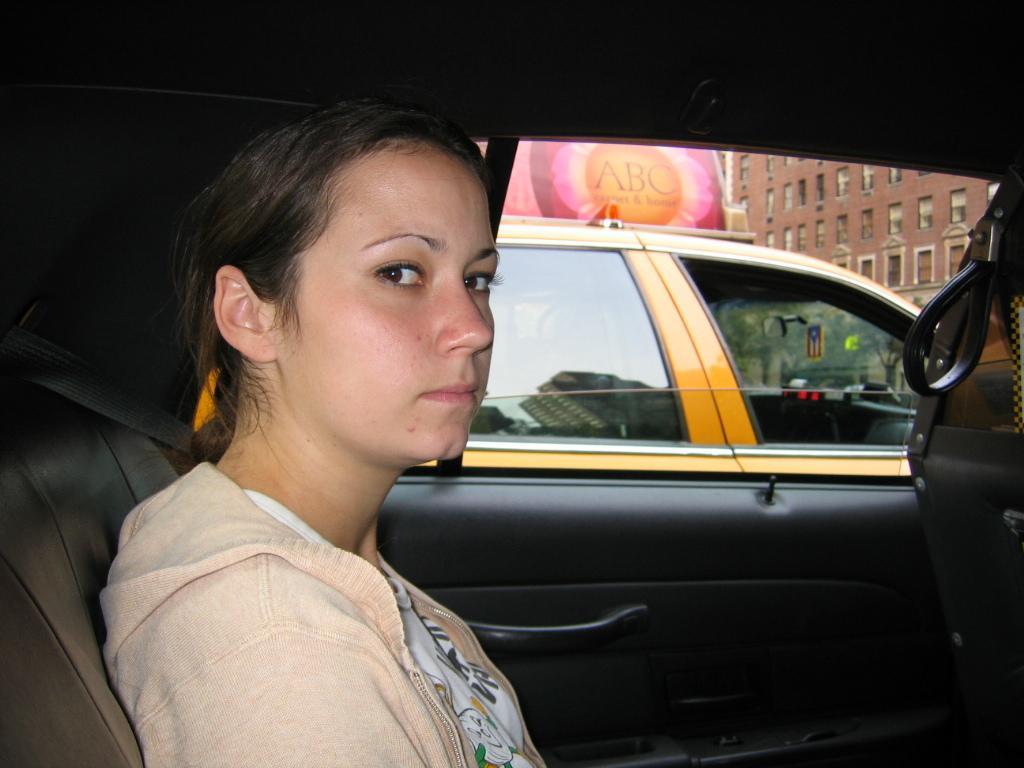What is the woman in the image doing? The woman is sitting inside a car. What else can be seen in the image besides the woman? There is a vehicle, trees, a poster, and a building in the background. Can you describe the background of the image? The background includes trees, a poster, and a building. What type of thrill ride can be seen in the background of the image? There is no thrill ride present in the image; it features a woman sitting inside a car and a background with trees, a poster, and a building. 